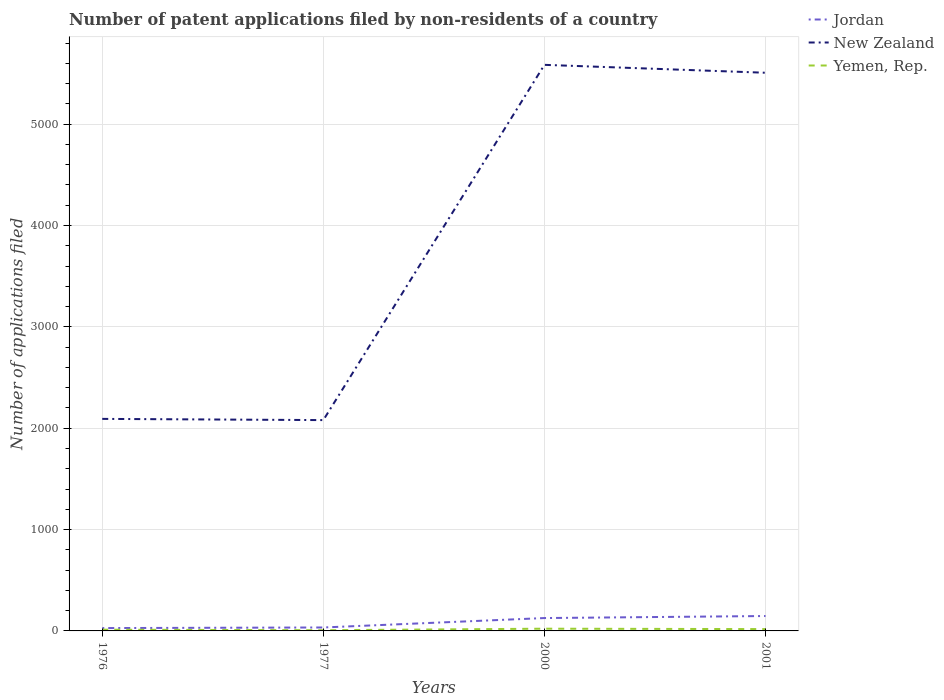Does the line corresponding to Jordan intersect with the line corresponding to New Zealand?
Make the answer very short. No. Is the number of lines equal to the number of legend labels?
Provide a short and direct response. Yes. Across all years, what is the maximum number of applications filed in Jordan?
Offer a terse response. 28. In which year was the number of applications filed in Jordan maximum?
Your answer should be very brief. 1976. What is the difference between the highest and the lowest number of applications filed in Jordan?
Keep it short and to the point. 2. Is the number of applications filed in Jordan strictly greater than the number of applications filed in New Zealand over the years?
Your answer should be compact. Yes. Does the graph contain any zero values?
Make the answer very short. No. What is the title of the graph?
Make the answer very short. Number of patent applications filed by non-residents of a country. What is the label or title of the X-axis?
Offer a very short reply. Years. What is the label or title of the Y-axis?
Provide a short and direct response. Number of applications filed. What is the Number of applications filed of New Zealand in 1976?
Make the answer very short. 2092. What is the Number of applications filed in New Zealand in 1977?
Offer a very short reply. 2080. What is the Number of applications filed in Jordan in 2000?
Make the answer very short. 127. What is the Number of applications filed of New Zealand in 2000?
Offer a very short reply. 5585. What is the Number of applications filed in Jordan in 2001?
Provide a succinct answer. 147. What is the Number of applications filed in New Zealand in 2001?
Offer a very short reply. 5507. What is the Number of applications filed of Yemen, Rep. in 2001?
Give a very brief answer. 18. Across all years, what is the maximum Number of applications filed in Jordan?
Your answer should be very brief. 147. Across all years, what is the maximum Number of applications filed of New Zealand?
Keep it short and to the point. 5585. Across all years, what is the minimum Number of applications filed in Jordan?
Give a very brief answer. 28. Across all years, what is the minimum Number of applications filed in New Zealand?
Your answer should be compact. 2080. What is the total Number of applications filed in Jordan in the graph?
Make the answer very short. 336. What is the total Number of applications filed of New Zealand in the graph?
Provide a succinct answer. 1.53e+04. What is the difference between the Number of applications filed in Jordan in 1976 and that in 1977?
Your answer should be very brief. -6. What is the difference between the Number of applications filed of New Zealand in 1976 and that in 1977?
Provide a short and direct response. 12. What is the difference between the Number of applications filed in Yemen, Rep. in 1976 and that in 1977?
Ensure brevity in your answer.  5. What is the difference between the Number of applications filed in Jordan in 1976 and that in 2000?
Provide a succinct answer. -99. What is the difference between the Number of applications filed of New Zealand in 1976 and that in 2000?
Provide a succinct answer. -3493. What is the difference between the Number of applications filed of Jordan in 1976 and that in 2001?
Your answer should be compact. -119. What is the difference between the Number of applications filed in New Zealand in 1976 and that in 2001?
Provide a succinct answer. -3415. What is the difference between the Number of applications filed in Jordan in 1977 and that in 2000?
Make the answer very short. -93. What is the difference between the Number of applications filed of New Zealand in 1977 and that in 2000?
Give a very brief answer. -3505. What is the difference between the Number of applications filed in Yemen, Rep. in 1977 and that in 2000?
Provide a succinct answer. -15. What is the difference between the Number of applications filed in Jordan in 1977 and that in 2001?
Keep it short and to the point. -113. What is the difference between the Number of applications filed in New Zealand in 1977 and that in 2001?
Your answer should be very brief. -3427. What is the difference between the Number of applications filed in Yemen, Rep. in 1977 and that in 2001?
Offer a terse response. -11. What is the difference between the Number of applications filed in Jordan in 1976 and the Number of applications filed in New Zealand in 1977?
Your answer should be very brief. -2052. What is the difference between the Number of applications filed of New Zealand in 1976 and the Number of applications filed of Yemen, Rep. in 1977?
Give a very brief answer. 2085. What is the difference between the Number of applications filed of Jordan in 1976 and the Number of applications filed of New Zealand in 2000?
Your answer should be compact. -5557. What is the difference between the Number of applications filed of Jordan in 1976 and the Number of applications filed of Yemen, Rep. in 2000?
Provide a succinct answer. 6. What is the difference between the Number of applications filed in New Zealand in 1976 and the Number of applications filed in Yemen, Rep. in 2000?
Your response must be concise. 2070. What is the difference between the Number of applications filed of Jordan in 1976 and the Number of applications filed of New Zealand in 2001?
Offer a very short reply. -5479. What is the difference between the Number of applications filed in New Zealand in 1976 and the Number of applications filed in Yemen, Rep. in 2001?
Your answer should be compact. 2074. What is the difference between the Number of applications filed in Jordan in 1977 and the Number of applications filed in New Zealand in 2000?
Give a very brief answer. -5551. What is the difference between the Number of applications filed of New Zealand in 1977 and the Number of applications filed of Yemen, Rep. in 2000?
Provide a succinct answer. 2058. What is the difference between the Number of applications filed in Jordan in 1977 and the Number of applications filed in New Zealand in 2001?
Keep it short and to the point. -5473. What is the difference between the Number of applications filed in New Zealand in 1977 and the Number of applications filed in Yemen, Rep. in 2001?
Provide a succinct answer. 2062. What is the difference between the Number of applications filed of Jordan in 2000 and the Number of applications filed of New Zealand in 2001?
Offer a terse response. -5380. What is the difference between the Number of applications filed of Jordan in 2000 and the Number of applications filed of Yemen, Rep. in 2001?
Your answer should be very brief. 109. What is the difference between the Number of applications filed in New Zealand in 2000 and the Number of applications filed in Yemen, Rep. in 2001?
Offer a terse response. 5567. What is the average Number of applications filed in Jordan per year?
Give a very brief answer. 84. What is the average Number of applications filed in New Zealand per year?
Offer a very short reply. 3816. What is the average Number of applications filed in Yemen, Rep. per year?
Your response must be concise. 14.75. In the year 1976, what is the difference between the Number of applications filed in Jordan and Number of applications filed in New Zealand?
Provide a short and direct response. -2064. In the year 1976, what is the difference between the Number of applications filed in New Zealand and Number of applications filed in Yemen, Rep.?
Keep it short and to the point. 2080. In the year 1977, what is the difference between the Number of applications filed in Jordan and Number of applications filed in New Zealand?
Make the answer very short. -2046. In the year 1977, what is the difference between the Number of applications filed of Jordan and Number of applications filed of Yemen, Rep.?
Offer a very short reply. 27. In the year 1977, what is the difference between the Number of applications filed of New Zealand and Number of applications filed of Yemen, Rep.?
Provide a succinct answer. 2073. In the year 2000, what is the difference between the Number of applications filed in Jordan and Number of applications filed in New Zealand?
Offer a terse response. -5458. In the year 2000, what is the difference between the Number of applications filed of Jordan and Number of applications filed of Yemen, Rep.?
Give a very brief answer. 105. In the year 2000, what is the difference between the Number of applications filed in New Zealand and Number of applications filed in Yemen, Rep.?
Your response must be concise. 5563. In the year 2001, what is the difference between the Number of applications filed in Jordan and Number of applications filed in New Zealand?
Give a very brief answer. -5360. In the year 2001, what is the difference between the Number of applications filed of Jordan and Number of applications filed of Yemen, Rep.?
Ensure brevity in your answer.  129. In the year 2001, what is the difference between the Number of applications filed of New Zealand and Number of applications filed of Yemen, Rep.?
Provide a short and direct response. 5489. What is the ratio of the Number of applications filed of Jordan in 1976 to that in 1977?
Your response must be concise. 0.82. What is the ratio of the Number of applications filed in Yemen, Rep. in 1976 to that in 1977?
Your response must be concise. 1.71. What is the ratio of the Number of applications filed in Jordan in 1976 to that in 2000?
Your answer should be very brief. 0.22. What is the ratio of the Number of applications filed in New Zealand in 1976 to that in 2000?
Keep it short and to the point. 0.37. What is the ratio of the Number of applications filed of Yemen, Rep. in 1976 to that in 2000?
Your answer should be compact. 0.55. What is the ratio of the Number of applications filed of Jordan in 1976 to that in 2001?
Offer a terse response. 0.19. What is the ratio of the Number of applications filed in New Zealand in 1976 to that in 2001?
Provide a succinct answer. 0.38. What is the ratio of the Number of applications filed of Yemen, Rep. in 1976 to that in 2001?
Make the answer very short. 0.67. What is the ratio of the Number of applications filed in Jordan in 1977 to that in 2000?
Provide a short and direct response. 0.27. What is the ratio of the Number of applications filed of New Zealand in 1977 to that in 2000?
Keep it short and to the point. 0.37. What is the ratio of the Number of applications filed in Yemen, Rep. in 1977 to that in 2000?
Your answer should be compact. 0.32. What is the ratio of the Number of applications filed of Jordan in 1977 to that in 2001?
Offer a terse response. 0.23. What is the ratio of the Number of applications filed in New Zealand in 1977 to that in 2001?
Your answer should be very brief. 0.38. What is the ratio of the Number of applications filed in Yemen, Rep. in 1977 to that in 2001?
Your answer should be very brief. 0.39. What is the ratio of the Number of applications filed of Jordan in 2000 to that in 2001?
Provide a short and direct response. 0.86. What is the ratio of the Number of applications filed in New Zealand in 2000 to that in 2001?
Give a very brief answer. 1.01. What is the ratio of the Number of applications filed of Yemen, Rep. in 2000 to that in 2001?
Give a very brief answer. 1.22. What is the difference between the highest and the second highest Number of applications filed in Jordan?
Offer a very short reply. 20. What is the difference between the highest and the second highest Number of applications filed in New Zealand?
Offer a terse response. 78. What is the difference between the highest and the second highest Number of applications filed in Yemen, Rep.?
Give a very brief answer. 4. What is the difference between the highest and the lowest Number of applications filed in Jordan?
Offer a terse response. 119. What is the difference between the highest and the lowest Number of applications filed in New Zealand?
Offer a very short reply. 3505. What is the difference between the highest and the lowest Number of applications filed in Yemen, Rep.?
Your answer should be very brief. 15. 